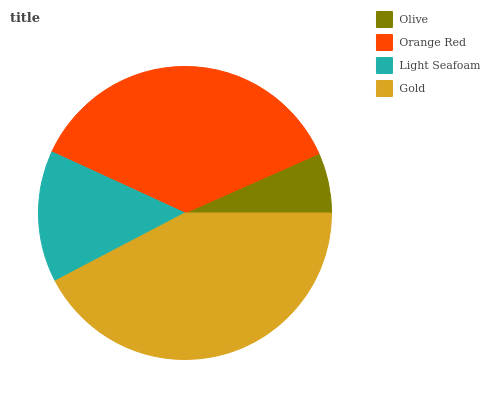Is Olive the minimum?
Answer yes or no. Yes. Is Gold the maximum?
Answer yes or no. Yes. Is Orange Red the minimum?
Answer yes or no. No. Is Orange Red the maximum?
Answer yes or no. No. Is Orange Red greater than Olive?
Answer yes or no. Yes. Is Olive less than Orange Red?
Answer yes or no. Yes. Is Olive greater than Orange Red?
Answer yes or no. No. Is Orange Red less than Olive?
Answer yes or no. No. Is Orange Red the high median?
Answer yes or no. Yes. Is Light Seafoam the low median?
Answer yes or no. Yes. Is Gold the high median?
Answer yes or no. No. Is Orange Red the low median?
Answer yes or no. No. 